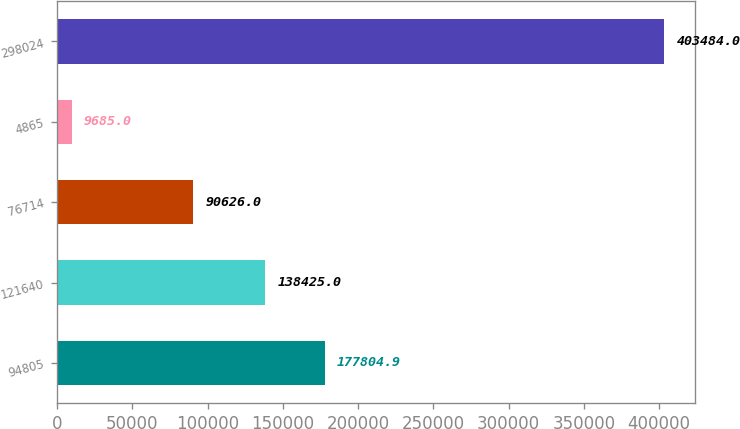Convert chart to OTSL. <chart><loc_0><loc_0><loc_500><loc_500><bar_chart><fcel>94805<fcel>121640<fcel>76714<fcel>4865<fcel>298024<nl><fcel>177805<fcel>138425<fcel>90626<fcel>9685<fcel>403484<nl></chart> 